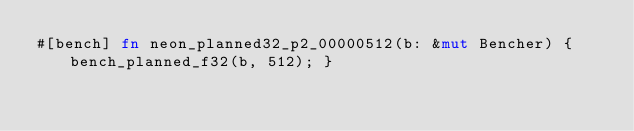<code> <loc_0><loc_0><loc_500><loc_500><_Rust_>#[bench] fn neon_planned32_p2_00000512(b: &mut Bencher) { bench_planned_f32(b, 512); }</code> 